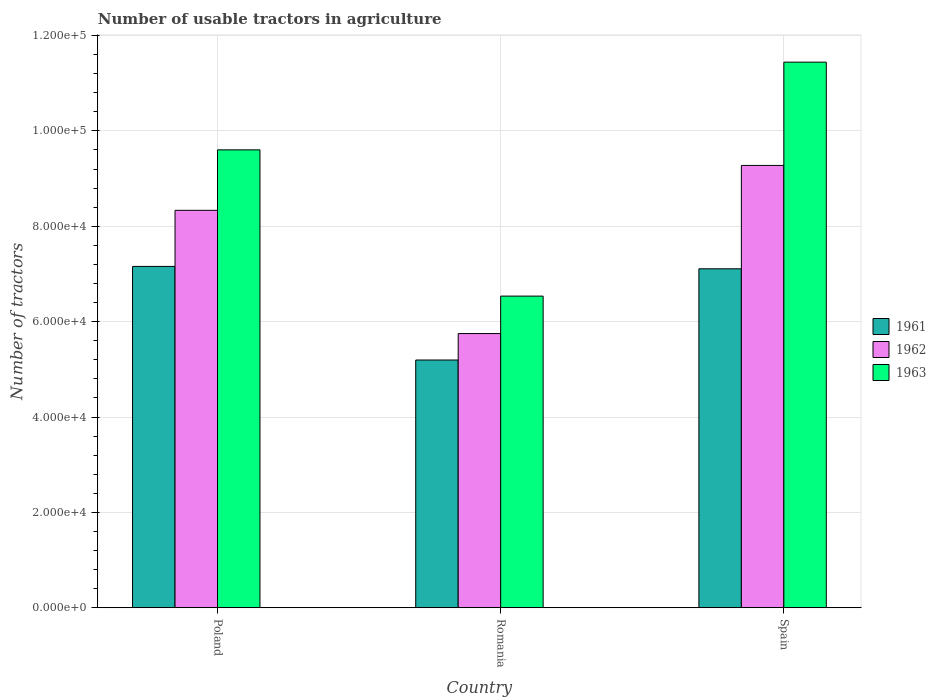How many groups of bars are there?
Offer a very short reply. 3. What is the label of the 2nd group of bars from the left?
Your response must be concise. Romania. What is the number of usable tractors in agriculture in 1961 in Romania?
Your answer should be very brief. 5.20e+04. Across all countries, what is the maximum number of usable tractors in agriculture in 1963?
Offer a very short reply. 1.14e+05. Across all countries, what is the minimum number of usable tractors in agriculture in 1962?
Give a very brief answer. 5.75e+04. In which country was the number of usable tractors in agriculture in 1961 maximum?
Provide a short and direct response. Poland. In which country was the number of usable tractors in agriculture in 1963 minimum?
Make the answer very short. Romania. What is the total number of usable tractors in agriculture in 1961 in the graph?
Your answer should be compact. 1.95e+05. What is the difference between the number of usable tractors in agriculture in 1961 in Poland and that in Romania?
Make the answer very short. 1.96e+04. What is the difference between the number of usable tractors in agriculture in 1963 in Spain and the number of usable tractors in agriculture in 1961 in Romania?
Provide a succinct answer. 6.25e+04. What is the average number of usable tractors in agriculture in 1962 per country?
Your answer should be very brief. 7.79e+04. What is the difference between the number of usable tractors in agriculture of/in 1963 and number of usable tractors in agriculture of/in 1961 in Poland?
Offer a terse response. 2.44e+04. What is the ratio of the number of usable tractors in agriculture in 1962 in Poland to that in Spain?
Ensure brevity in your answer.  0.9. What is the difference between the highest and the second highest number of usable tractors in agriculture in 1963?
Give a very brief answer. 1.84e+04. What is the difference between the highest and the lowest number of usable tractors in agriculture in 1962?
Make the answer very short. 3.53e+04. In how many countries, is the number of usable tractors in agriculture in 1961 greater than the average number of usable tractors in agriculture in 1961 taken over all countries?
Offer a very short reply. 2. What does the 3rd bar from the left in Poland represents?
Offer a terse response. 1963. What does the 2nd bar from the right in Poland represents?
Offer a very short reply. 1962. How many bars are there?
Offer a very short reply. 9. How many countries are there in the graph?
Ensure brevity in your answer.  3. What is the difference between two consecutive major ticks on the Y-axis?
Your answer should be compact. 2.00e+04. Does the graph contain any zero values?
Offer a very short reply. No. Does the graph contain grids?
Make the answer very short. Yes. Where does the legend appear in the graph?
Provide a short and direct response. Center right. How many legend labels are there?
Your answer should be compact. 3. How are the legend labels stacked?
Keep it short and to the point. Vertical. What is the title of the graph?
Offer a very short reply. Number of usable tractors in agriculture. Does "1999" appear as one of the legend labels in the graph?
Provide a succinct answer. No. What is the label or title of the Y-axis?
Your answer should be very brief. Number of tractors. What is the Number of tractors in 1961 in Poland?
Keep it short and to the point. 7.16e+04. What is the Number of tractors in 1962 in Poland?
Provide a succinct answer. 8.33e+04. What is the Number of tractors of 1963 in Poland?
Your answer should be compact. 9.60e+04. What is the Number of tractors in 1961 in Romania?
Your answer should be very brief. 5.20e+04. What is the Number of tractors of 1962 in Romania?
Your answer should be compact. 5.75e+04. What is the Number of tractors of 1963 in Romania?
Offer a terse response. 6.54e+04. What is the Number of tractors of 1961 in Spain?
Your answer should be compact. 7.11e+04. What is the Number of tractors in 1962 in Spain?
Your answer should be compact. 9.28e+04. What is the Number of tractors of 1963 in Spain?
Your answer should be compact. 1.14e+05. Across all countries, what is the maximum Number of tractors in 1961?
Your answer should be very brief. 7.16e+04. Across all countries, what is the maximum Number of tractors of 1962?
Offer a terse response. 9.28e+04. Across all countries, what is the maximum Number of tractors in 1963?
Offer a terse response. 1.14e+05. Across all countries, what is the minimum Number of tractors in 1961?
Your response must be concise. 5.20e+04. Across all countries, what is the minimum Number of tractors of 1962?
Keep it short and to the point. 5.75e+04. Across all countries, what is the minimum Number of tractors of 1963?
Ensure brevity in your answer.  6.54e+04. What is the total Number of tractors in 1961 in the graph?
Your response must be concise. 1.95e+05. What is the total Number of tractors of 1962 in the graph?
Ensure brevity in your answer.  2.34e+05. What is the total Number of tractors in 1963 in the graph?
Give a very brief answer. 2.76e+05. What is the difference between the Number of tractors in 1961 in Poland and that in Romania?
Provide a short and direct response. 1.96e+04. What is the difference between the Number of tractors of 1962 in Poland and that in Romania?
Keep it short and to the point. 2.58e+04. What is the difference between the Number of tractors of 1963 in Poland and that in Romania?
Your response must be concise. 3.07e+04. What is the difference between the Number of tractors in 1961 in Poland and that in Spain?
Your answer should be very brief. 500. What is the difference between the Number of tractors in 1962 in Poland and that in Spain?
Make the answer very short. -9414. What is the difference between the Number of tractors in 1963 in Poland and that in Spain?
Make the answer very short. -1.84e+04. What is the difference between the Number of tractors of 1961 in Romania and that in Spain?
Make the answer very short. -1.91e+04. What is the difference between the Number of tractors in 1962 in Romania and that in Spain?
Offer a terse response. -3.53e+04. What is the difference between the Number of tractors of 1963 in Romania and that in Spain?
Make the answer very short. -4.91e+04. What is the difference between the Number of tractors in 1961 in Poland and the Number of tractors in 1962 in Romania?
Give a very brief answer. 1.41e+04. What is the difference between the Number of tractors of 1961 in Poland and the Number of tractors of 1963 in Romania?
Your answer should be compact. 6226. What is the difference between the Number of tractors of 1962 in Poland and the Number of tractors of 1963 in Romania?
Provide a short and direct response. 1.80e+04. What is the difference between the Number of tractors in 1961 in Poland and the Number of tractors in 1962 in Spain?
Make the answer very short. -2.12e+04. What is the difference between the Number of tractors in 1961 in Poland and the Number of tractors in 1963 in Spain?
Keep it short and to the point. -4.28e+04. What is the difference between the Number of tractors of 1962 in Poland and the Number of tractors of 1963 in Spain?
Make the answer very short. -3.11e+04. What is the difference between the Number of tractors of 1961 in Romania and the Number of tractors of 1962 in Spain?
Offer a very short reply. -4.08e+04. What is the difference between the Number of tractors in 1961 in Romania and the Number of tractors in 1963 in Spain?
Your response must be concise. -6.25e+04. What is the difference between the Number of tractors in 1962 in Romania and the Number of tractors in 1963 in Spain?
Your answer should be very brief. -5.69e+04. What is the average Number of tractors of 1961 per country?
Your answer should be compact. 6.49e+04. What is the average Number of tractors of 1962 per country?
Your response must be concise. 7.79e+04. What is the average Number of tractors of 1963 per country?
Offer a terse response. 9.19e+04. What is the difference between the Number of tractors in 1961 and Number of tractors in 1962 in Poland?
Provide a short and direct response. -1.18e+04. What is the difference between the Number of tractors in 1961 and Number of tractors in 1963 in Poland?
Provide a succinct answer. -2.44e+04. What is the difference between the Number of tractors of 1962 and Number of tractors of 1963 in Poland?
Offer a very short reply. -1.27e+04. What is the difference between the Number of tractors in 1961 and Number of tractors in 1962 in Romania?
Offer a very short reply. -5548. What is the difference between the Number of tractors in 1961 and Number of tractors in 1963 in Romania?
Keep it short and to the point. -1.34e+04. What is the difference between the Number of tractors in 1962 and Number of tractors in 1963 in Romania?
Provide a short and direct response. -7851. What is the difference between the Number of tractors of 1961 and Number of tractors of 1962 in Spain?
Keep it short and to the point. -2.17e+04. What is the difference between the Number of tractors in 1961 and Number of tractors in 1963 in Spain?
Make the answer very short. -4.33e+04. What is the difference between the Number of tractors in 1962 and Number of tractors in 1963 in Spain?
Your response must be concise. -2.17e+04. What is the ratio of the Number of tractors of 1961 in Poland to that in Romania?
Offer a very short reply. 1.38. What is the ratio of the Number of tractors of 1962 in Poland to that in Romania?
Offer a terse response. 1.45. What is the ratio of the Number of tractors of 1963 in Poland to that in Romania?
Offer a very short reply. 1.47. What is the ratio of the Number of tractors in 1961 in Poland to that in Spain?
Your answer should be compact. 1.01. What is the ratio of the Number of tractors of 1962 in Poland to that in Spain?
Keep it short and to the point. 0.9. What is the ratio of the Number of tractors in 1963 in Poland to that in Spain?
Give a very brief answer. 0.84. What is the ratio of the Number of tractors in 1961 in Romania to that in Spain?
Ensure brevity in your answer.  0.73. What is the ratio of the Number of tractors in 1962 in Romania to that in Spain?
Your answer should be very brief. 0.62. What is the ratio of the Number of tractors in 1963 in Romania to that in Spain?
Keep it short and to the point. 0.57. What is the difference between the highest and the second highest Number of tractors of 1962?
Provide a short and direct response. 9414. What is the difference between the highest and the second highest Number of tractors of 1963?
Ensure brevity in your answer.  1.84e+04. What is the difference between the highest and the lowest Number of tractors of 1961?
Provide a succinct answer. 1.96e+04. What is the difference between the highest and the lowest Number of tractors of 1962?
Give a very brief answer. 3.53e+04. What is the difference between the highest and the lowest Number of tractors in 1963?
Keep it short and to the point. 4.91e+04. 